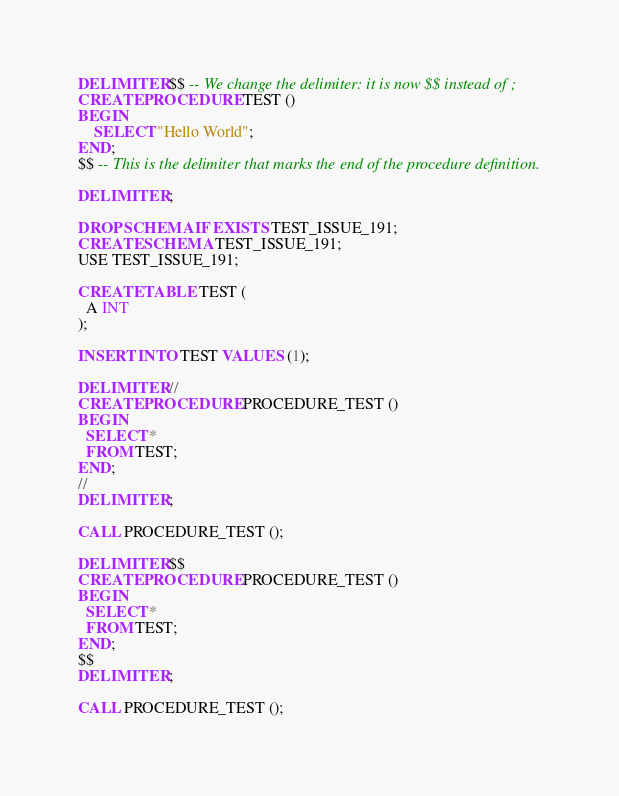<code> <loc_0><loc_0><loc_500><loc_500><_SQL_>DELIMITER $$ -- We change the delimiter: it is now $$ instead of ;
CREATE PROCEDURE TEST ()
BEGIN
    SELECT "Hello World";
END;
$$ -- This is the delimiter that marks the end of the procedure definition.

DELIMITER ;

DROP SCHEMA IF EXISTS TEST_ISSUE_191;
CREATE SCHEMA TEST_ISSUE_191;
USE TEST_ISSUE_191;

CREATE TABLE TEST (
  A INT
);

INSERT INTO TEST VALUES (1);

DELIMITER //
CREATE PROCEDURE PROCEDURE_TEST ()
BEGIN
  SELECT *
  FROM TEST;
END;
//
DELIMITER ;

CALL PROCEDURE_TEST ();

DELIMITER $$
CREATE PROCEDURE PROCEDURE_TEST ()
BEGIN
  SELECT *
  FROM TEST;
END;
$$
DELIMITER ;

CALL PROCEDURE_TEST ();

</code> 